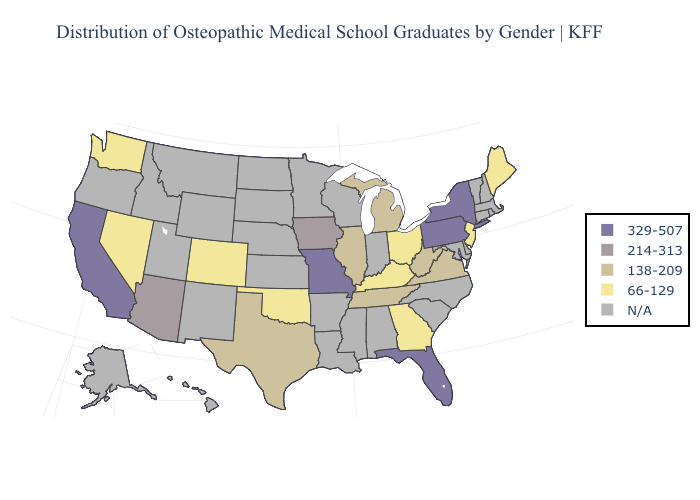What is the lowest value in the MidWest?
Quick response, please. 66-129. What is the value of Mississippi?
Keep it brief. N/A. Name the states that have a value in the range 214-313?
Short answer required. Arizona, Iowa. What is the lowest value in the South?
Be succinct. 66-129. Name the states that have a value in the range N/A?
Write a very short answer. Alabama, Alaska, Arkansas, Connecticut, Delaware, Hawaii, Idaho, Indiana, Kansas, Louisiana, Maryland, Massachusetts, Minnesota, Mississippi, Montana, Nebraska, New Hampshire, New Mexico, North Carolina, North Dakota, Oregon, Rhode Island, South Carolina, South Dakota, Utah, Vermont, Wisconsin, Wyoming. What is the lowest value in states that border Florida?
Quick response, please. 66-129. Name the states that have a value in the range N/A?
Concise answer only. Alabama, Alaska, Arkansas, Connecticut, Delaware, Hawaii, Idaho, Indiana, Kansas, Louisiana, Maryland, Massachusetts, Minnesota, Mississippi, Montana, Nebraska, New Hampshire, New Mexico, North Carolina, North Dakota, Oregon, Rhode Island, South Carolina, South Dakota, Utah, Vermont, Wisconsin, Wyoming. Does California have the highest value in the West?
Write a very short answer. Yes. Does Tennessee have the lowest value in the South?
Concise answer only. No. What is the value of Minnesota?
Write a very short answer. N/A. What is the highest value in the USA?
Short answer required. 329-507. What is the value of Ohio?
Give a very brief answer. 66-129. Does Nevada have the highest value in the USA?
Concise answer only. No. 